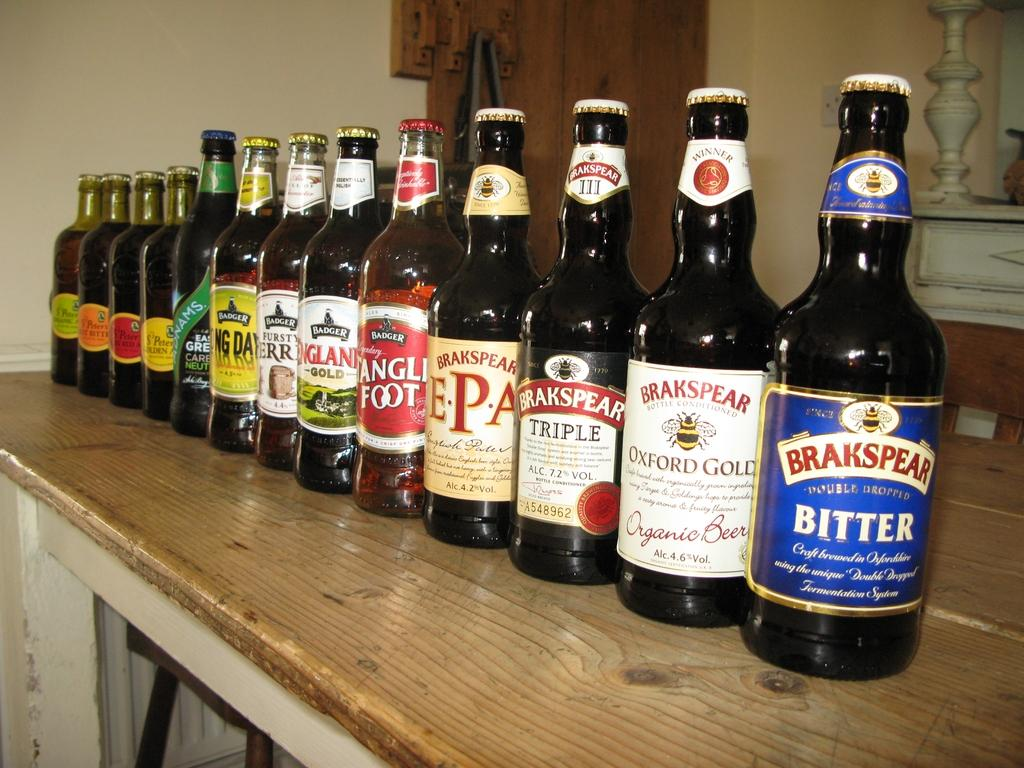<image>
Summarize the visual content of the image. several bottles of liquor displayed including ones by Brakspear 